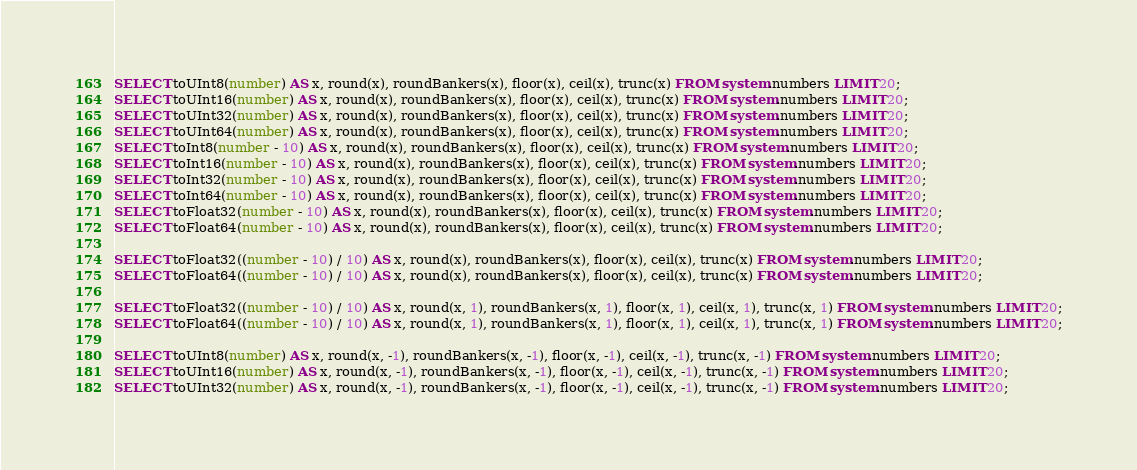<code> <loc_0><loc_0><loc_500><loc_500><_SQL_>SELECT toUInt8(number) AS x, round(x), roundBankers(x), floor(x), ceil(x), trunc(x) FROM system.numbers LIMIT 20;
SELECT toUInt16(number) AS x, round(x), roundBankers(x), floor(x), ceil(x), trunc(x) FROM system.numbers LIMIT 20;
SELECT toUInt32(number) AS x, round(x), roundBankers(x), floor(x), ceil(x), trunc(x) FROM system.numbers LIMIT 20;
SELECT toUInt64(number) AS x, round(x), roundBankers(x), floor(x), ceil(x), trunc(x) FROM system.numbers LIMIT 20;
SELECT toInt8(number - 10) AS x, round(x), roundBankers(x), floor(x), ceil(x), trunc(x) FROM system.numbers LIMIT 20;
SELECT toInt16(number - 10) AS x, round(x), roundBankers(x), floor(x), ceil(x), trunc(x) FROM system.numbers LIMIT 20;
SELECT toInt32(number - 10) AS x, round(x), roundBankers(x), floor(x), ceil(x), trunc(x) FROM system.numbers LIMIT 20;
SELECT toInt64(number - 10) AS x, round(x), roundBankers(x), floor(x), ceil(x), trunc(x) FROM system.numbers LIMIT 20;
SELECT toFloat32(number - 10) AS x, round(x), roundBankers(x), floor(x), ceil(x), trunc(x) FROM system.numbers LIMIT 20;
SELECT toFloat64(number - 10) AS x, round(x), roundBankers(x), floor(x), ceil(x), trunc(x) FROM system.numbers LIMIT 20;

SELECT toFloat32((number - 10) / 10) AS x, round(x), roundBankers(x), floor(x), ceil(x), trunc(x) FROM system.numbers LIMIT 20;
SELECT toFloat64((number - 10) / 10) AS x, round(x), roundBankers(x), floor(x), ceil(x), trunc(x) FROM system.numbers LIMIT 20;

SELECT toFloat32((number - 10) / 10) AS x, round(x, 1), roundBankers(x, 1), floor(x, 1), ceil(x, 1), trunc(x, 1) FROM system.numbers LIMIT 20;
SELECT toFloat64((number - 10) / 10) AS x, round(x, 1), roundBankers(x, 1), floor(x, 1), ceil(x, 1), trunc(x, 1) FROM system.numbers LIMIT 20;

SELECT toUInt8(number) AS x, round(x, -1), roundBankers(x, -1), floor(x, -1), ceil(x, -1), trunc(x, -1) FROM system.numbers LIMIT 20;
SELECT toUInt16(number) AS x, round(x, -1), roundBankers(x, -1), floor(x, -1), ceil(x, -1), trunc(x, -1) FROM system.numbers LIMIT 20;
SELECT toUInt32(number) AS x, round(x, -1), roundBankers(x, -1), floor(x, -1), ceil(x, -1), trunc(x, -1) FROM system.numbers LIMIT 20;</code> 